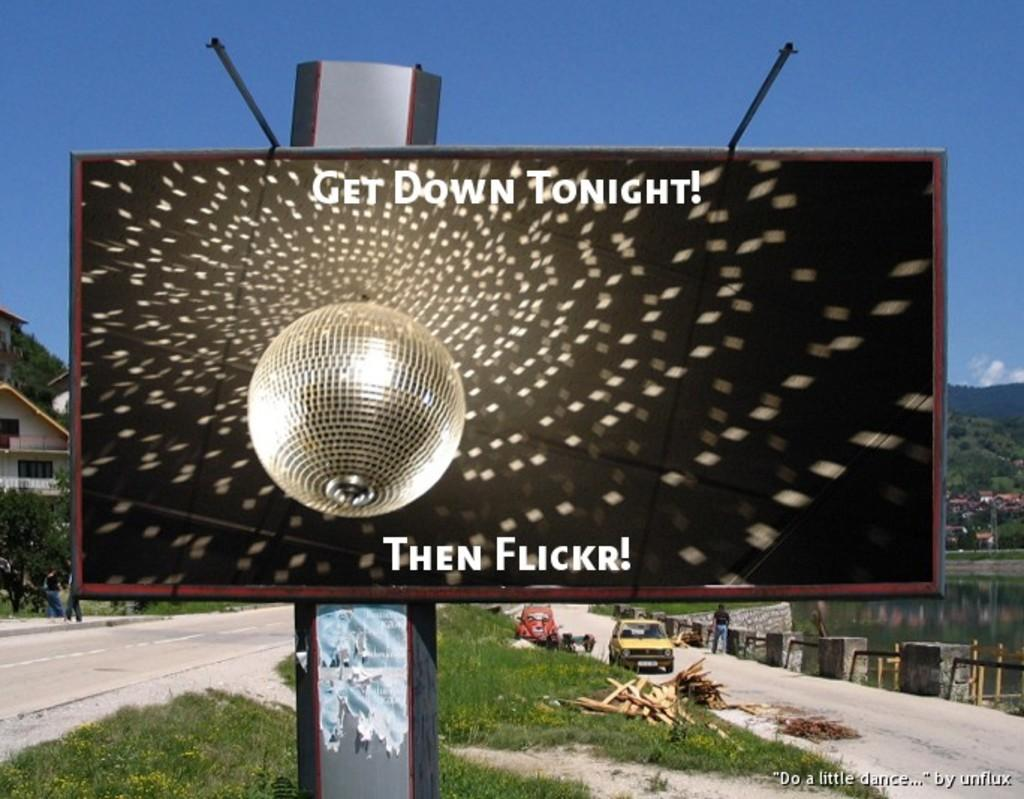<image>
Offer a succinct explanation of the picture presented. An outdoor monitor with an ad that reads Get Down Tonight. 